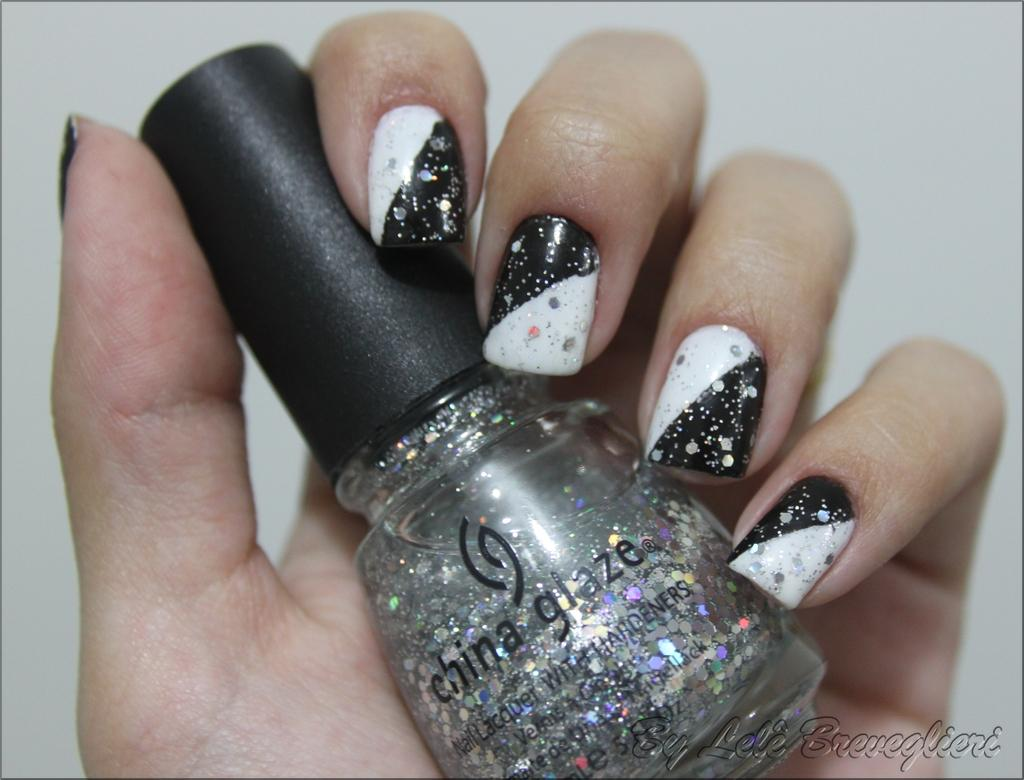What is the main subject of the image? The main subject of the image is a human. What is the human holding in the image? The human is holding a nail polish bottle. What is the color of the nail polish bottle? The nail polish bottle is black in color. How many hands does the human have in the image? The provided facts do not mention the number of hands the human has in the image. What wish does the human have while holding the nail polish bottle? The provided facts do not mention any wishes the human might have while holding the nail polish bottle. Are the human's family members present in the image? The provided facts do not mention the presence of family members in the image. 